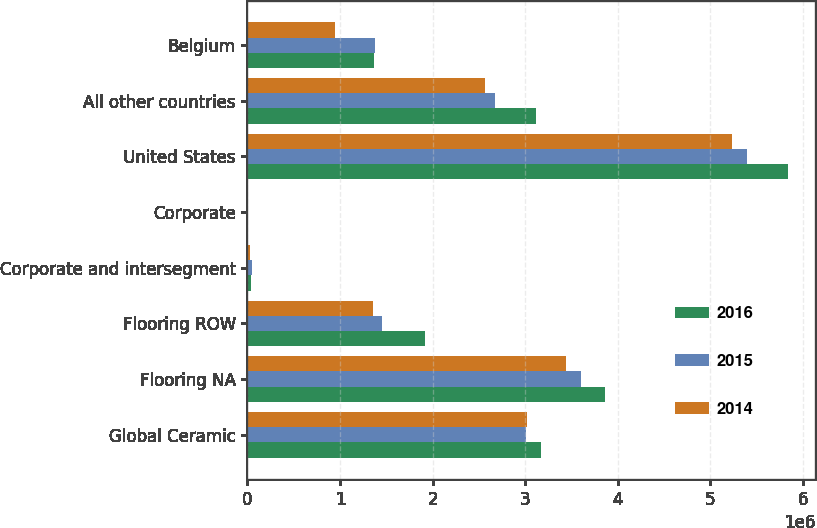Convert chart to OTSL. <chart><loc_0><loc_0><loc_500><loc_500><stacked_bar_chart><ecel><fcel>Global Ceramic<fcel>Flooring NA<fcel>Flooring ROW<fcel>Corporate and intersegment<fcel>Corporate<fcel>United States<fcel>All other countries<fcel>Belgium<nl><fcel>2016<fcel>3.17471e+06<fcel>3.86575e+06<fcel>1.91864e+06<fcel>36711<fcel>9982<fcel>5.84268e+06<fcel>3.1164e+06<fcel>1.3714e+06<nl><fcel>2015<fcel>3.01286e+06<fcel>3.60211e+06<fcel>1.4569e+06<fcel>44229<fcel>9543<fcel>5.39956e+06<fcel>2.672e+06<fcel>1.37753e+06<nl><fcel>2014<fcel>3.01528e+06<fcel>3.44102e+06<fcel>1.35402e+06<fcel>29837<fcel>10682<fcel>5.2338e+06<fcel>2.56965e+06<fcel>949169<nl></chart> 